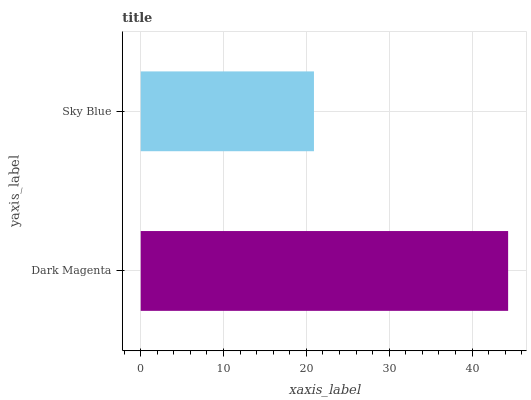Is Sky Blue the minimum?
Answer yes or no. Yes. Is Dark Magenta the maximum?
Answer yes or no. Yes. Is Sky Blue the maximum?
Answer yes or no. No. Is Dark Magenta greater than Sky Blue?
Answer yes or no. Yes. Is Sky Blue less than Dark Magenta?
Answer yes or no. Yes. Is Sky Blue greater than Dark Magenta?
Answer yes or no. No. Is Dark Magenta less than Sky Blue?
Answer yes or no. No. Is Dark Magenta the high median?
Answer yes or no. Yes. Is Sky Blue the low median?
Answer yes or no. Yes. Is Sky Blue the high median?
Answer yes or no. No. Is Dark Magenta the low median?
Answer yes or no. No. 